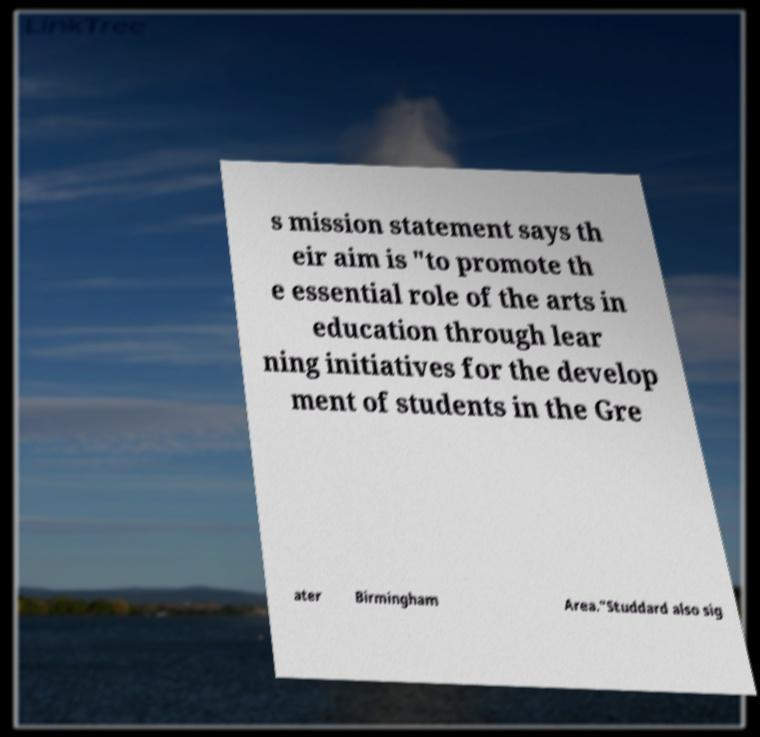Can you read and provide the text displayed in the image?This photo seems to have some interesting text. Can you extract and type it out for me? s mission statement says th eir aim is "to promote th e essential role of the arts in education through lear ning initiatives for the develop ment of students in the Gre ater Birmingham Area."Studdard also sig 